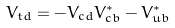<formula> <loc_0><loc_0><loc_500><loc_500>V _ { t d } = - V _ { c d } V ^ { * } _ { c b } - V ^ { * } _ { u b }</formula> 